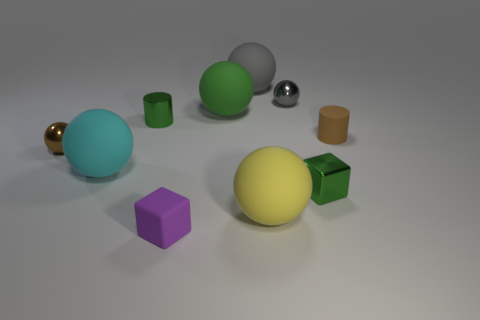What number of green things are tiny metallic balls or tiny matte cylinders?
Offer a very short reply. 0. How many other things are there of the same shape as the big cyan rubber object?
Keep it short and to the point. 5. There is a rubber object to the right of the tiny shiny cube; is its color the same as the metallic sphere in front of the matte cylinder?
Offer a terse response. Yes. How many big objects are either yellow objects or rubber things?
Make the answer very short. 4. There is a yellow object that is the same shape as the large green object; what is its size?
Keep it short and to the point. Large. What is the material of the small green thing that is on the left side of the small metal sphere behind the rubber cylinder?
Provide a short and direct response. Metal. How many rubber things are small green blocks or large cyan balls?
Provide a succinct answer. 1. There is another small object that is the same shape as the small purple rubber thing; what color is it?
Your answer should be very brief. Green. How many small objects have the same color as the small metal cylinder?
Keep it short and to the point. 1. Is there a big green ball that is on the right side of the tiny sphere that is on the left side of the yellow ball?
Keep it short and to the point. Yes. 